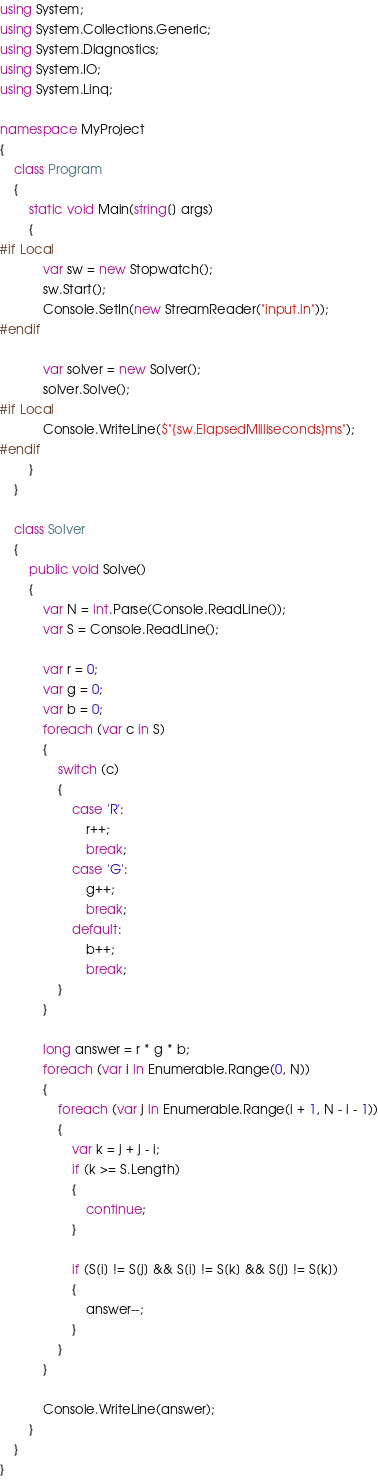<code> <loc_0><loc_0><loc_500><loc_500><_C#_>using System;
using System.Collections.Generic;
using System.Diagnostics;
using System.IO;
using System.Linq;

namespace MyProject
{
    class Program
    {
        static void Main(string[] args)
        {
#if Local
            var sw = new Stopwatch();
            sw.Start();
            Console.SetIn(new StreamReader("input.in"));
#endif

            var solver = new Solver();
            solver.Solve();
#if Local
            Console.WriteLine($"{sw.ElapsedMilliseconds}ms");
#endif
        }
    }

    class Solver
    {
        public void Solve()
        {
            var N = int.Parse(Console.ReadLine());
            var S = Console.ReadLine();

            var r = 0;
            var g = 0;
            var b = 0;
            foreach (var c in S)
            {
                switch (c)
                {
                    case 'R':
                        r++;
                        break;
                    case 'G':
                        g++;
                        break;
                    default:
                        b++;
                        break;
                }
            }

            long answer = r * g * b;
            foreach (var i in Enumerable.Range(0, N))
            {
                foreach (var j in Enumerable.Range(i + 1, N - i - 1))
                {
                    var k = j + j - i;
                    if (k >= S.Length)
                    {
                        continue;
                    }

                    if (S[i] != S[j] && S[i] != S[k] && S[j] != S[k])
                    {
                        answer--;
                    }
                }
            }

            Console.WriteLine(answer);
        }
    }
}
</code> 